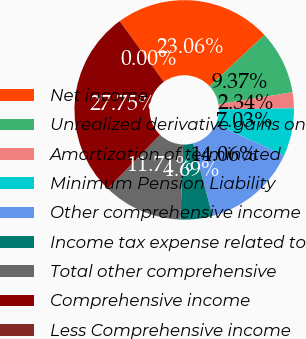Convert chart to OTSL. <chart><loc_0><loc_0><loc_500><loc_500><pie_chart><fcel>Net income<fcel>Unrealized derivative gains on<fcel>Amortization of terminated<fcel>Minimum Pension Liability<fcel>Other comprehensive income<fcel>Income tax expense related to<fcel>Total other comprehensive<fcel>Comprehensive income<fcel>Less Comprehensive income<nl><fcel>23.06%<fcel>9.37%<fcel>2.34%<fcel>7.03%<fcel>14.06%<fcel>4.69%<fcel>11.71%<fcel>27.75%<fcel>0.0%<nl></chart> 